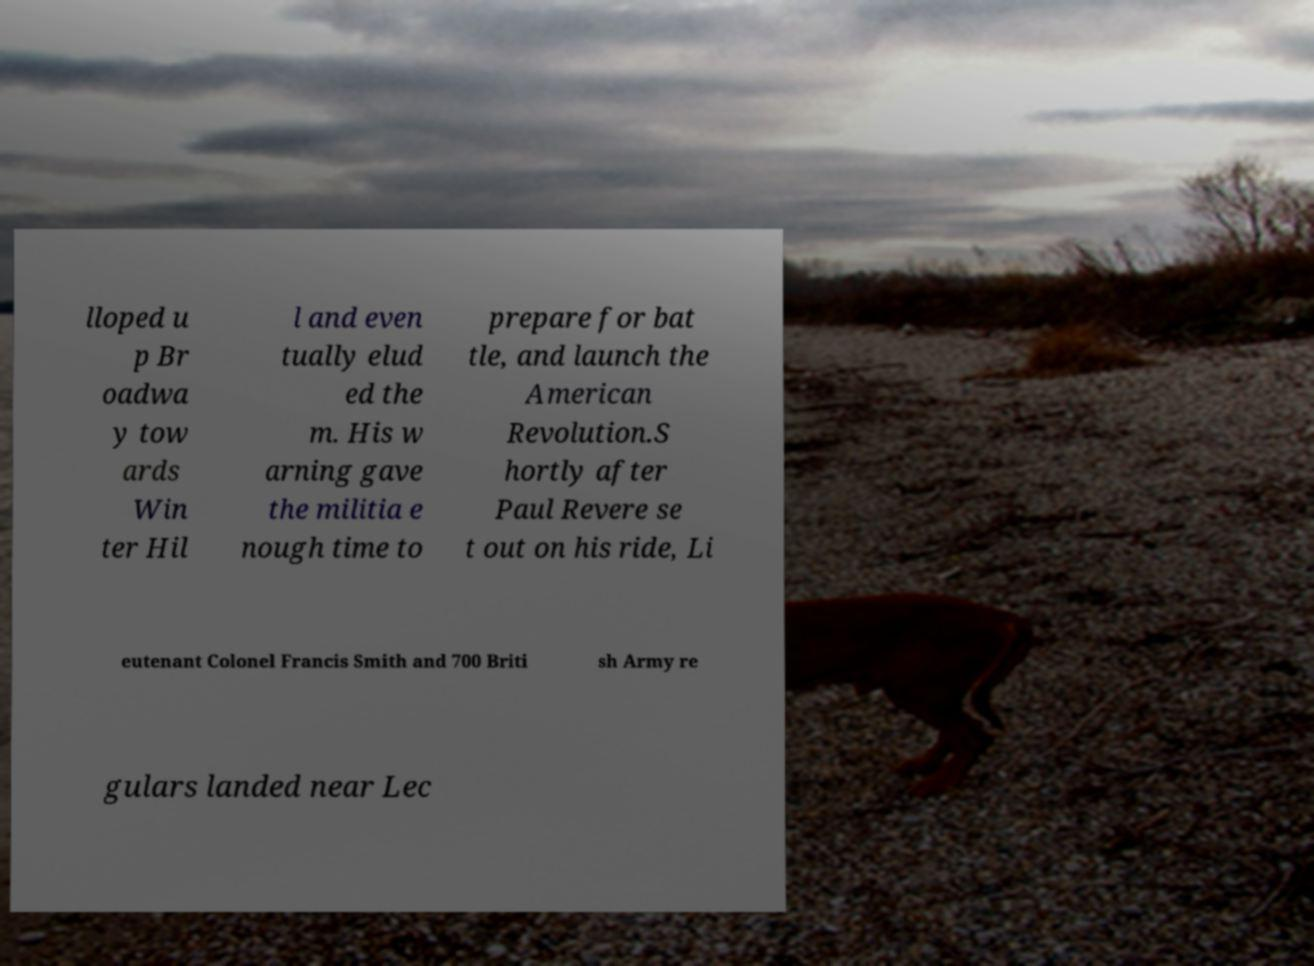I need the written content from this picture converted into text. Can you do that? lloped u p Br oadwa y tow ards Win ter Hil l and even tually elud ed the m. His w arning gave the militia e nough time to prepare for bat tle, and launch the American Revolution.S hortly after Paul Revere se t out on his ride, Li eutenant Colonel Francis Smith and 700 Briti sh Army re gulars landed near Lec 